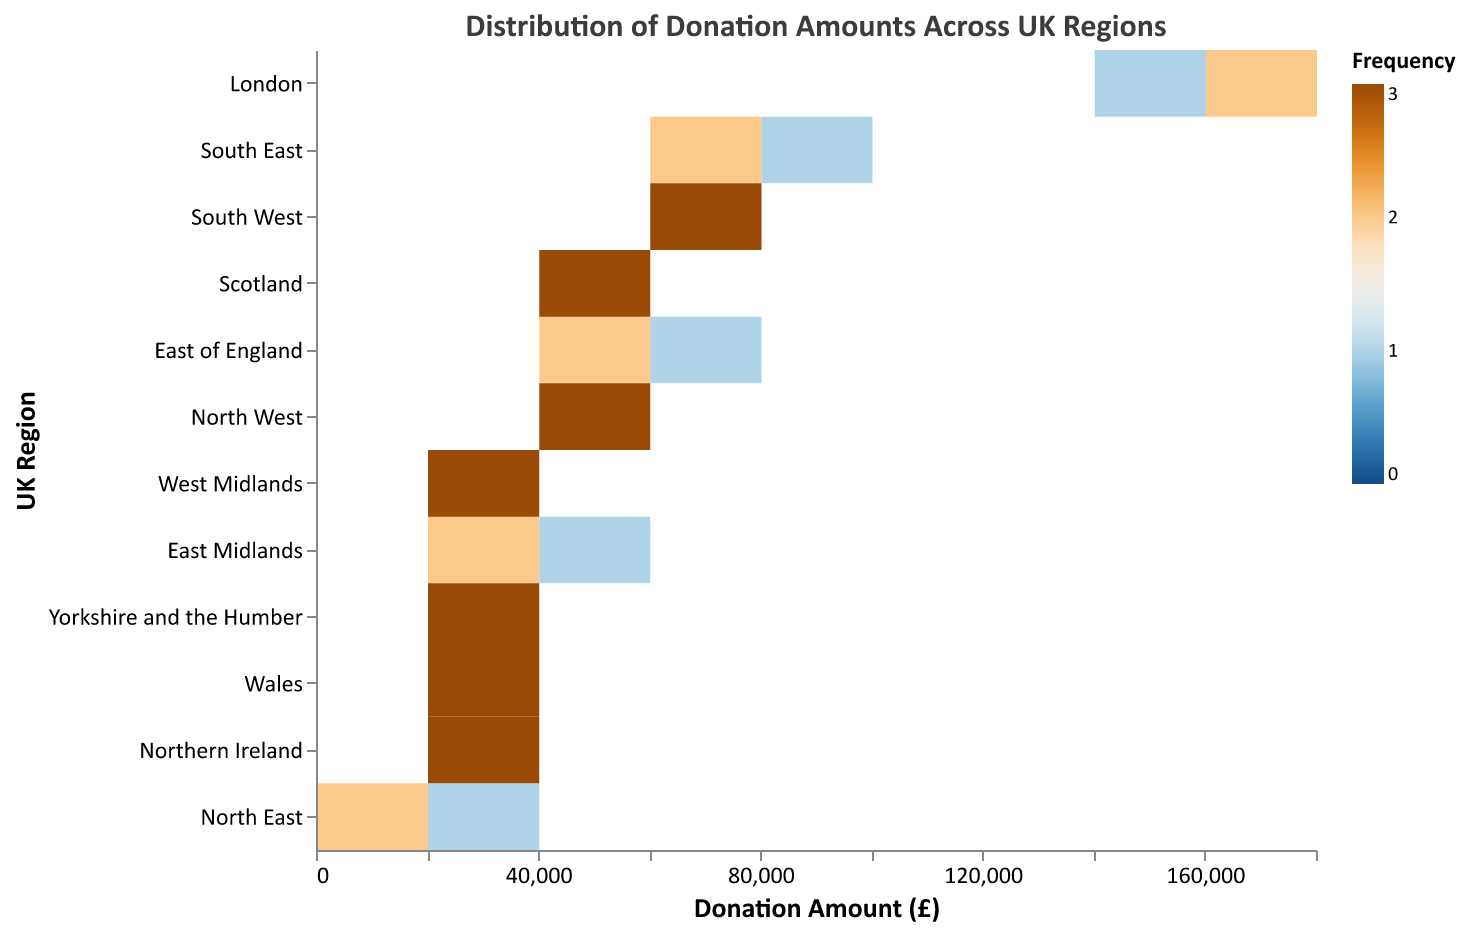What is the title of the figure? The title of the figure is typically placed at the top and indicates the main purpose of the visualization, which in this case is the "Distribution of Donation Amounts Across UK Regions".
Answer: Distribution of Donation Amounts Across UK Regions What are the regions represented on the y-axis? The y-axis of the heatmap lists all UK regions where data is collected, which includes "East of England", "East Midlands", "London", "North East", "North West", "South East", "South West", "West Midlands", "Yorkshire and the Humber", "Scotland", "Wales", and "Northern Ireland".
Answer: East of England, East Midlands, London, North East, North West, South East, South West, West Midlands, Yorkshire and the Humber, Scotland, Wales, Northern Ireland Which region shows the highest frequency of high donation amounts? By examining the intensity of the colors in the heatmap, the region with the darkest shade in the higher donation bins (on the x-axis) indicates the highest frequency of high donation amounts. In this case, it is "London".
Answer: London Which region has the most even distribution of donation amounts across different bins? To determine the most even distribution, observe the color gradient of each region. Regions with a mixed color range across the donation amount bins indicate an even distribution. Here, "Scotland" and "South East" appear to have a relatively balanced distribution across donation bins.
Answer: Scotland, South East What is the approximate range of donation amounts for "East Midlands"? In the heatmap, find the region "East Midlands" on the y-axis and look at the x-axis bins it spans. The donation amounts for "East Midlands" are in the range of 32,000 to 41,000.
Answer: 32,000 to 41,000 Which regions have donation amounts in the same range as "Northern Ireland"? By comparing the color bins of "Northern Ireland" to other regions, notice that "Northern Ireland" donations span from 21,000 to 23,000. "Wales" has a similar range of donation amounts.
Answer: Wales Which region has the lowest donation amount? Look at the lowest bin on the x-axis and identify the corresponding region on the y-axis. "North East" shows the lowest donation amount, which is approximately 18,000.
Answer: North East What is the frequency of donations in the 70,000 to 82,000 range? In the given range, check the color intensity on the x-axis and refer to the color legend for frequency. The darker the color, the higher the frequency. Regions like "South East" show higher frequencies in this bin.
Answer: South East How do the donation amounts in "Yorkshire and the Humber" compare to those in "West Midlands"? Compare the color distribution along the x-axis for both regions. "Yorkshire and the Humber" has donations ranging from 30,000 to 34,000, while "West Midlands" ranges from 35,000 to 37,000. "West Midlands" has slightly higher donation amounts than "Yorkshire and the Humber".
Answer: West Midlands What does the x-axis represent in this heatmap? The x-axis indicates the donation amounts in pounds (£) and is divided into bins for visualizing the frequency distribution of donations.
Answer: Donation Amount (£) 